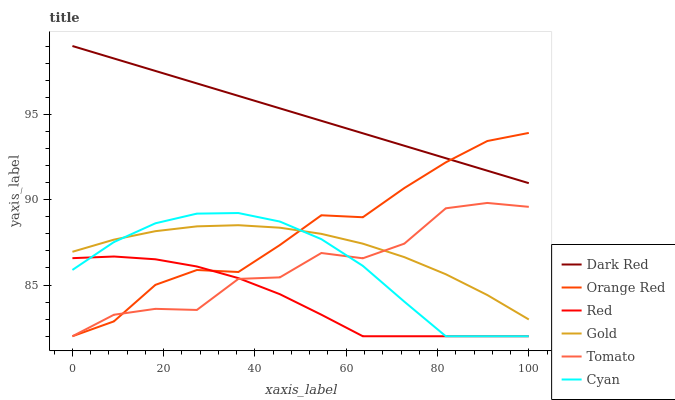Does Red have the minimum area under the curve?
Answer yes or no. Yes. Does Dark Red have the maximum area under the curve?
Answer yes or no. Yes. Does Gold have the minimum area under the curve?
Answer yes or no. No. Does Gold have the maximum area under the curve?
Answer yes or no. No. Is Dark Red the smoothest?
Answer yes or no. Yes. Is Tomato the roughest?
Answer yes or no. Yes. Is Gold the smoothest?
Answer yes or no. No. Is Gold the roughest?
Answer yes or no. No. Does Gold have the lowest value?
Answer yes or no. No. Does Dark Red have the highest value?
Answer yes or no. Yes. Does Gold have the highest value?
Answer yes or no. No. Is Red less than Gold?
Answer yes or no. Yes. Is Dark Red greater than Tomato?
Answer yes or no. Yes. Does Dark Red intersect Orange Red?
Answer yes or no. Yes. Is Dark Red less than Orange Red?
Answer yes or no. No. Is Dark Red greater than Orange Red?
Answer yes or no. No. Does Red intersect Gold?
Answer yes or no. No. 